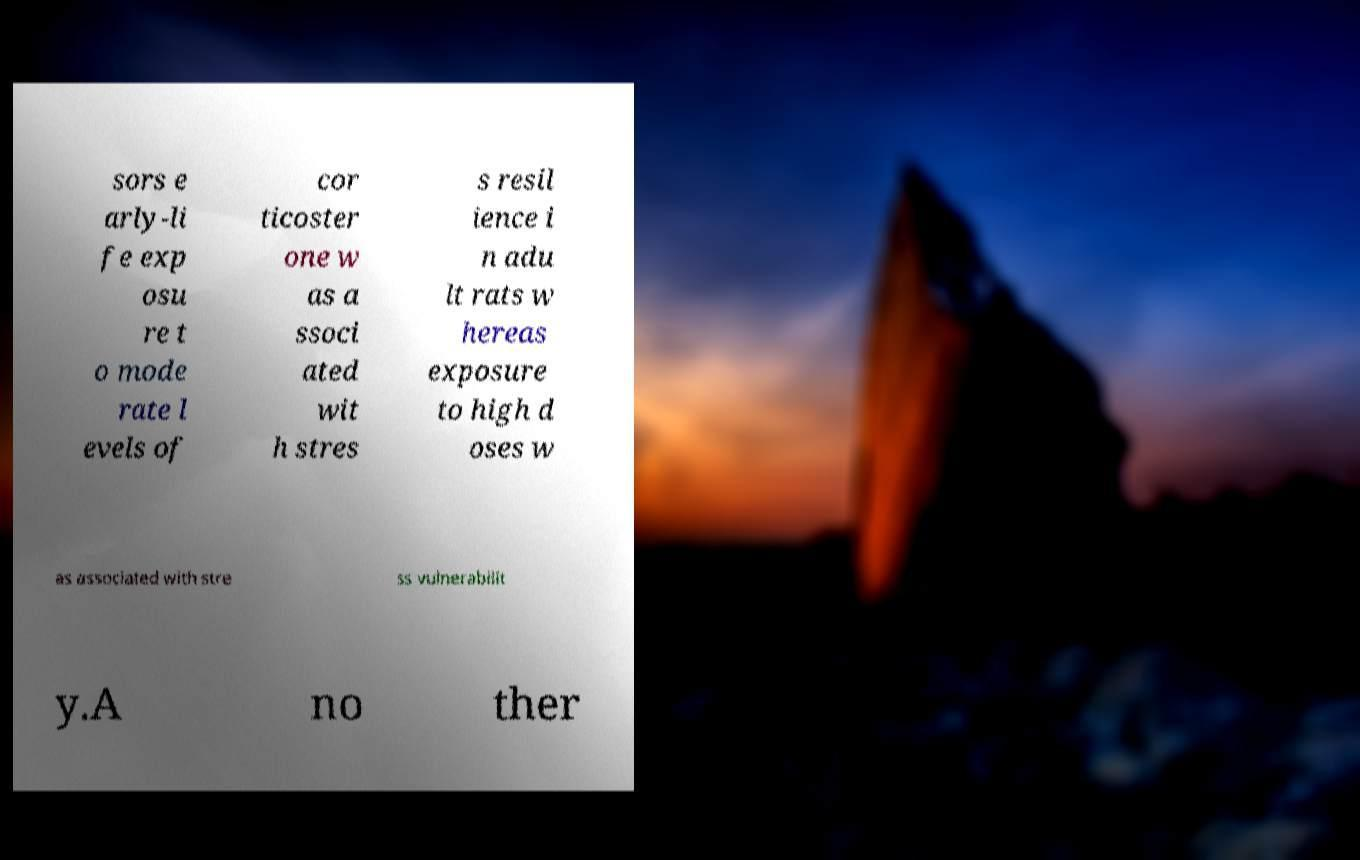For documentation purposes, I need the text within this image transcribed. Could you provide that? sors e arly-li fe exp osu re t o mode rate l evels of cor ticoster one w as a ssoci ated wit h stres s resil ience i n adu lt rats w hereas exposure to high d oses w as associated with stre ss vulnerabilit y.A no ther 